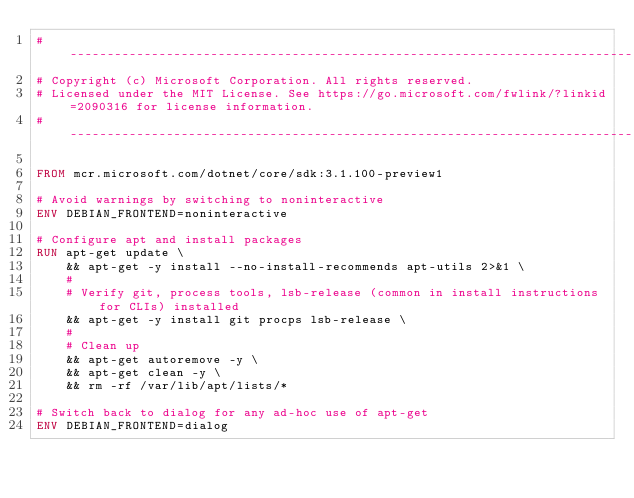<code> <loc_0><loc_0><loc_500><loc_500><_Dockerfile_>#-------------------------------------------------------------------------------------------------------------
# Copyright (c) Microsoft Corporation. All rights reserved.
# Licensed under the MIT License. See https://go.microsoft.com/fwlink/?linkid=2090316 for license information.
#-------------------------------------------------------------------------------------------------------------

FROM mcr.microsoft.com/dotnet/core/sdk:3.1.100-preview1

# Avoid warnings by switching to noninteractive
ENV DEBIAN_FRONTEND=noninteractive

# Configure apt and install packages
RUN apt-get update \
    && apt-get -y install --no-install-recommends apt-utils 2>&1 \
    #
    # Verify git, process tools, lsb-release (common in install instructions for CLIs) installed
    && apt-get -y install git procps lsb-release \
    #
    # Clean up
    && apt-get autoremove -y \
    && apt-get clean -y \
    && rm -rf /var/lib/apt/lists/*

# Switch back to dialog for any ad-hoc use of apt-get
ENV DEBIAN_FRONTEND=dialog
</code> 